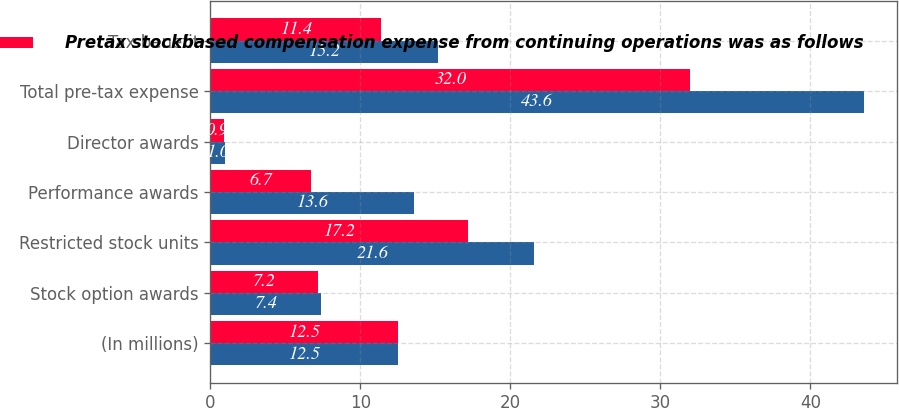<chart> <loc_0><loc_0><loc_500><loc_500><stacked_bar_chart><ecel><fcel>(In millions)<fcel>Stock option awards<fcel>Restricted stock units<fcel>Performance awards<fcel>Director awards<fcel>Total pre-tax expense<fcel>Tax benefit<nl><fcel>nan<fcel>12.5<fcel>7.4<fcel>21.6<fcel>13.6<fcel>1<fcel>43.6<fcel>15.2<nl><fcel>Pretax stockbased compensation expense from continuing operations was as follows<fcel>12.5<fcel>7.2<fcel>17.2<fcel>6.7<fcel>0.9<fcel>32<fcel>11.4<nl></chart> 